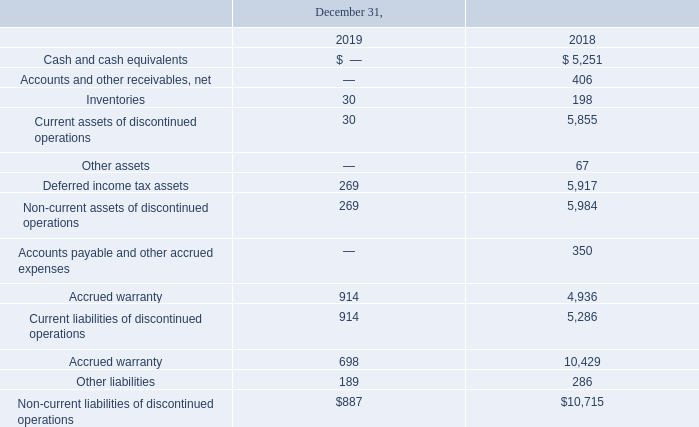Discontinued Operations
In December 2015, we completed the wind down of engineering, manufacturing and sales of our solar inverter product line (the "inverter business"). Accordingly, the results of our inverter business have been reflected as “Income (loss) from discontinued operations, net of income taxes” on our Consolidated Statements of Operations for all periods presented herein.
The effect of our sales of extended inverter warranties to our customers continues to be reflected in deferred revenue in our Consolidated Balance Sheets. Deferred revenue for extended inverter warranties and the associated costs of warranty service will be reflected in Sales and Cost of goods sold, respectively, from continuing operations in future periods in our Consolidated Statement of Operations, as the deferred revenue, is earned and the associated services are rendered. Extended warranties related to the inverter product line are no longer offered.
ADVANCED ENERGY INDUSTRIES, INC. NOTES TO CONSOLIDATED FINANCIAL STATEMENTS – (continued) (in thousands, except per share amounts)
Assets and Liabilities of discontinued operations within the Consolidated Balance Sheets are comprised of the following:
When did the winding down of engineering, manufacturing and sales of solar inverter product line occur? December 2015. What was the Cash and cash equivalents in 2018?
Answer scale should be: thousand. $ 5,251. What were the Inventories in 2019?
Answer scale should be: thousand. 30. What was the change in current assets of discontinued operations between 2018 and 2019?
Answer scale should be: thousand. 30-5,855
Answer: -5825. What was the change in Accrued warranty of Accounts payable and other accrued expenses between 2018 and 2019?
Answer scale should be: thousand. 914-4,936
Answer: -4022. What is the percentage change in Non-current liabilities of discontinued operations between 2018 and 2019?
Answer scale should be: percent. ($887-$10,715)/$10,715
Answer: -91.72. 